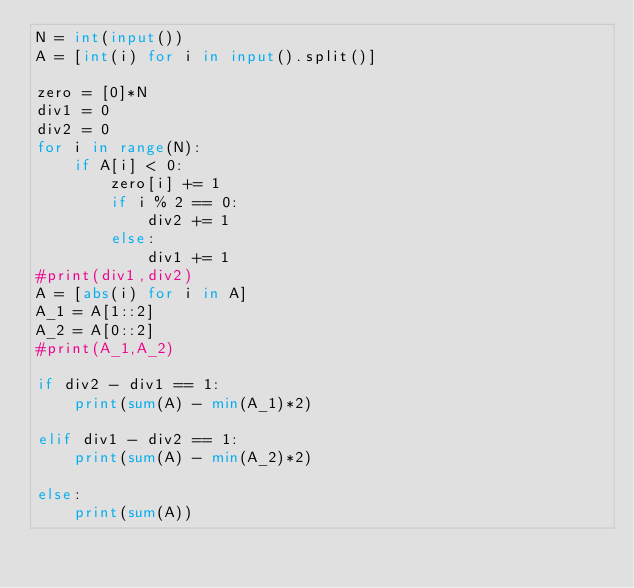Convert code to text. <code><loc_0><loc_0><loc_500><loc_500><_Python_>N = int(input())
A = [int(i) for i in input().split()]

zero = [0]*N
div1 = 0
div2 = 0
for i in range(N):
    if A[i] < 0:
        zero[i] += 1
        if i % 2 == 0:
            div2 += 1
        else:
            div1 += 1
#print(div1,div2)
A = [abs(i) for i in A]
A_1 = A[1::2]
A_2 = A[0::2]
#print(A_1,A_2)

if div2 - div1 == 1:
    print(sum(A) - min(A_1)*2)

elif div1 - div2 == 1:
    print(sum(A) - min(A_2)*2)

else:
    print(sum(A))

</code> 